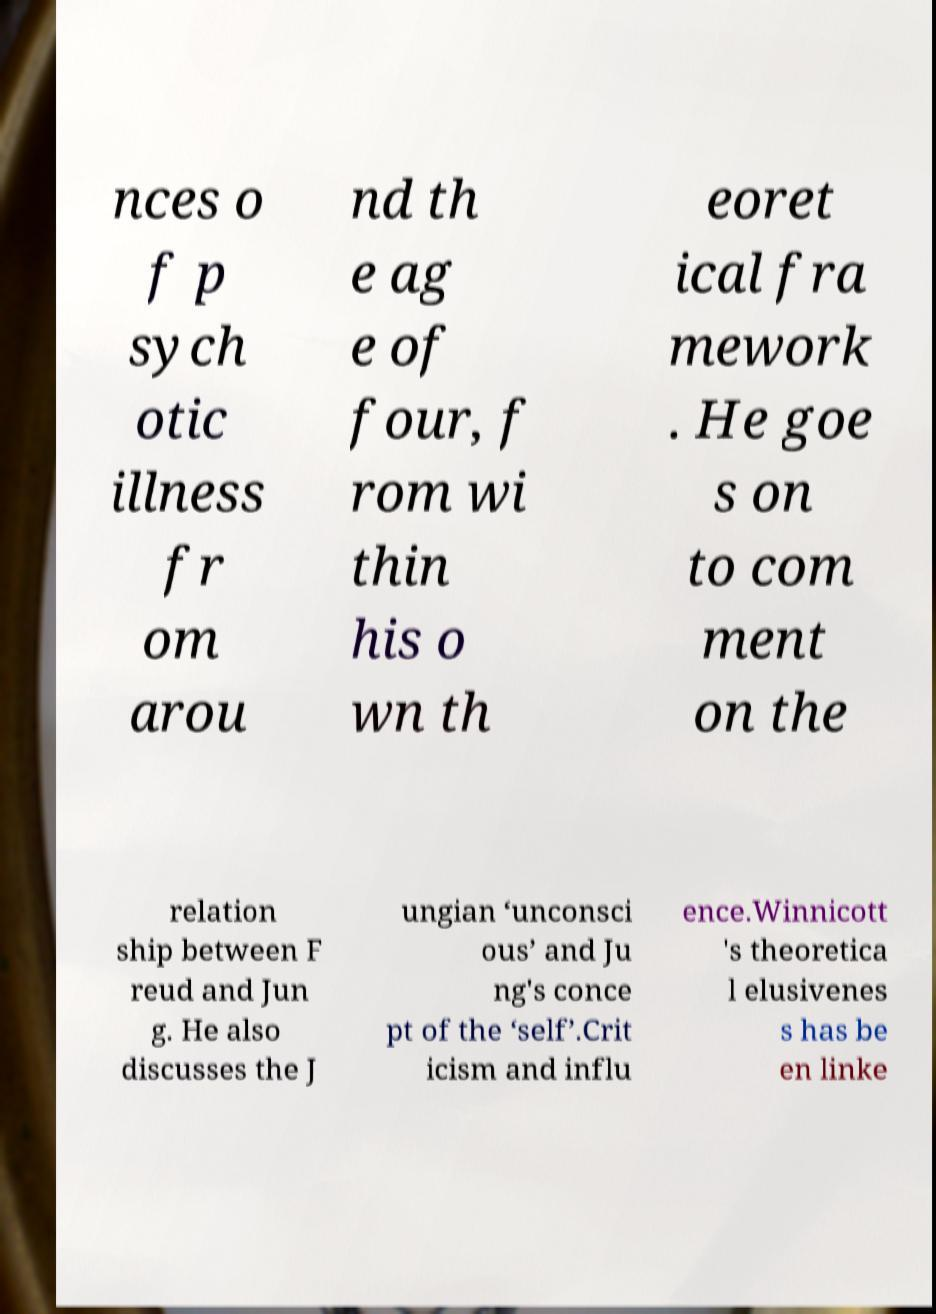I need the written content from this picture converted into text. Can you do that? nces o f p sych otic illness fr om arou nd th e ag e of four, f rom wi thin his o wn th eoret ical fra mework . He goe s on to com ment on the relation ship between F reud and Jun g. He also discusses the J ungian ‘unconsci ous’ and Ju ng's conce pt of the ‘self’.Crit icism and influ ence.Winnicott 's theoretica l elusivenes s has be en linke 